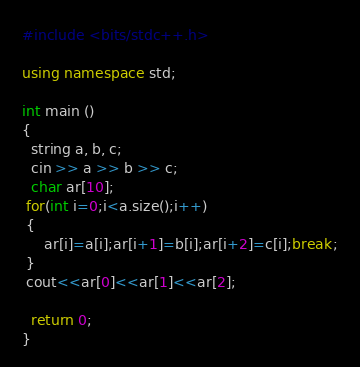<code> <loc_0><loc_0><loc_500><loc_500><_C++_>#include <bits/stdc++.h>

using namespace std;

int main ()
{
  string a, b, c;
  cin >> a >> b >> c;
  char ar[10];
 for(int i=0;i<a.size();i++)
 {
     ar[i]=a[i];ar[i+1]=b[i];ar[i+2]=c[i];break;
 }
 cout<<ar[0]<<ar[1]<<ar[2];
 
  return 0;
}
</code> 